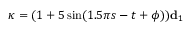Convert formula to latex. <formula><loc_0><loc_0><loc_500><loc_500>\kappa = ( 1 + 5 \sin ( 1 . 5 \pi s - t + \phi ) ) d _ { 1 }</formula> 